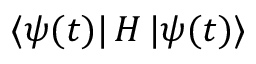<formula> <loc_0><loc_0><loc_500><loc_500>\ m a t h i n n e r { \langle { \psi ( t ) } | } H \ m a t h i n n e r { | { \psi ( t ) } \rangle }</formula> 